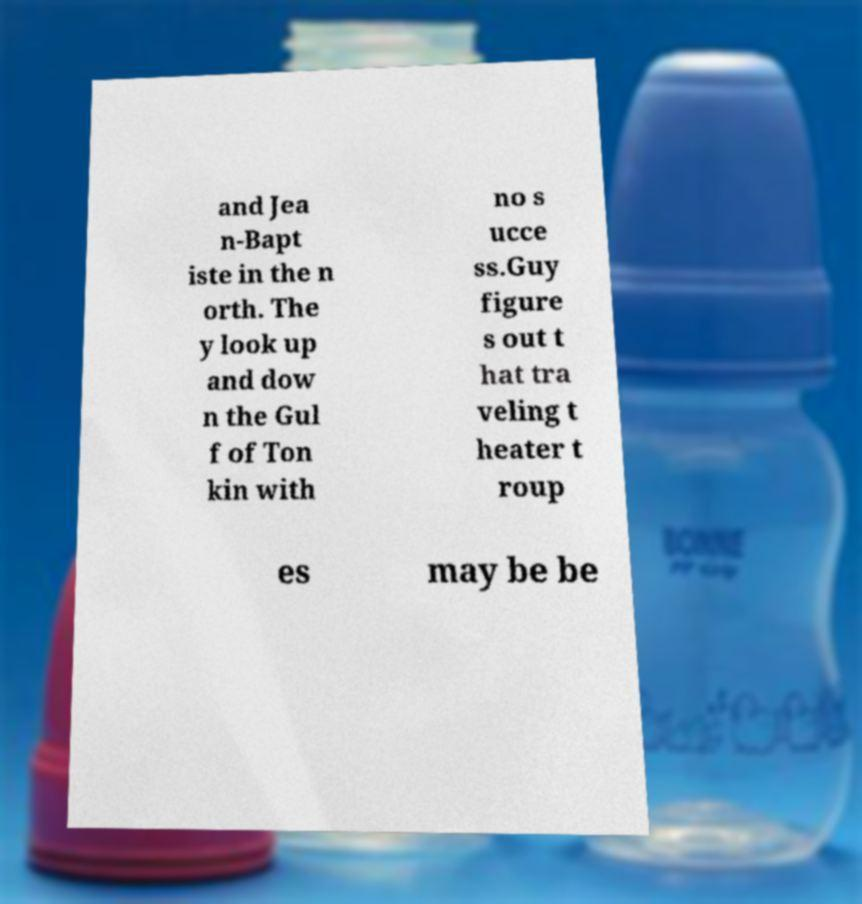Can you read and provide the text displayed in the image?This photo seems to have some interesting text. Can you extract and type it out for me? and Jea n-Bapt iste in the n orth. The y look up and dow n the Gul f of Ton kin with no s ucce ss.Guy figure s out t hat tra veling t heater t roup es may be be 